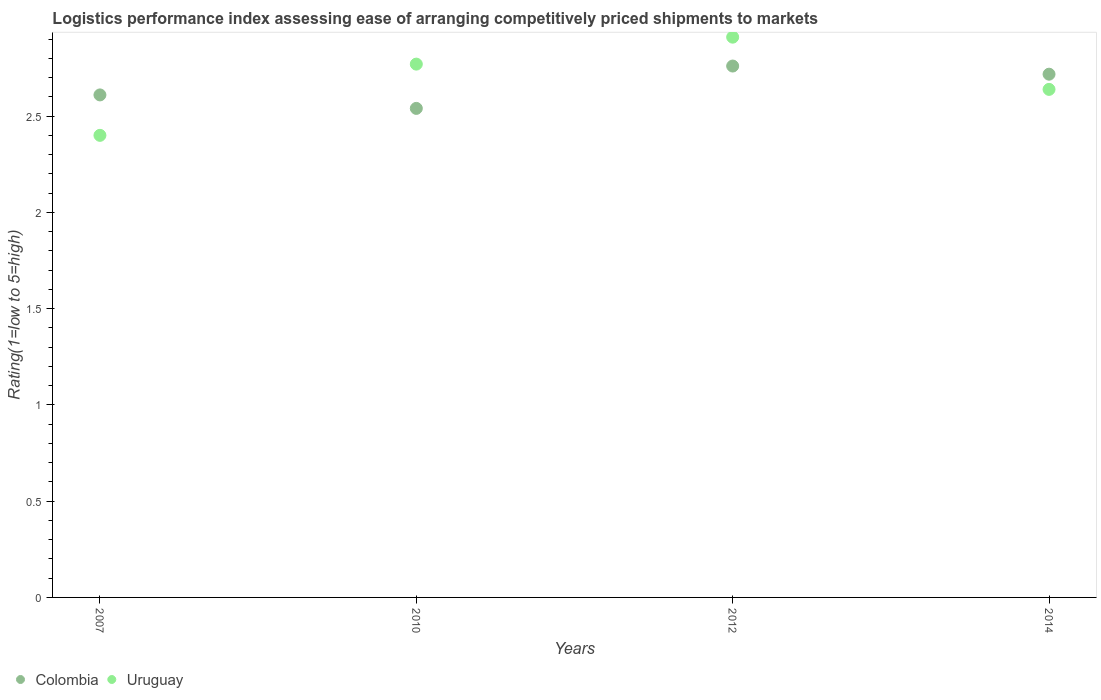Is the number of dotlines equal to the number of legend labels?
Your answer should be compact. Yes. What is the Logistic performance index in Colombia in 2007?
Your answer should be compact. 2.61. Across all years, what is the maximum Logistic performance index in Colombia?
Make the answer very short. 2.76. Across all years, what is the minimum Logistic performance index in Colombia?
Your response must be concise. 2.54. In which year was the Logistic performance index in Colombia minimum?
Your answer should be very brief. 2010. What is the total Logistic performance index in Uruguay in the graph?
Offer a very short reply. 10.72. What is the difference between the Logistic performance index in Uruguay in 2007 and that in 2012?
Offer a terse response. -0.51. What is the difference between the Logistic performance index in Uruguay in 2014 and the Logistic performance index in Colombia in 2007?
Keep it short and to the point. 0.03. What is the average Logistic performance index in Colombia per year?
Your response must be concise. 2.66. In the year 2012, what is the difference between the Logistic performance index in Uruguay and Logistic performance index in Colombia?
Provide a succinct answer. 0.15. In how many years, is the Logistic performance index in Uruguay greater than 1.4?
Offer a terse response. 4. What is the ratio of the Logistic performance index in Uruguay in 2010 to that in 2014?
Provide a short and direct response. 1.05. Is the difference between the Logistic performance index in Uruguay in 2012 and 2014 greater than the difference between the Logistic performance index in Colombia in 2012 and 2014?
Ensure brevity in your answer.  Yes. What is the difference between the highest and the second highest Logistic performance index in Uruguay?
Offer a terse response. 0.14. What is the difference between the highest and the lowest Logistic performance index in Uruguay?
Offer a very short reply. 0.51. In how many years, is the Logistic performance index in Colombia greater than the average Logistic performance index in Colombia taken over all years?
Your answer should be compact. 2. Does the Logistic performance index in Uruguay monotonically increase over the years?
Your answer should be compact. No. How many years are there in the graph?
Your answer should be very brief. 4. What is the difference between two consecutive major ticks on the Y-axis?
Offer a terse response. 0.5. Does the graph contain grids?
Your answer should be very brief. No. Where does the legend appear in the graph?
Offer a very short reply. Bottom left. What is the title of the graph?
Give a very brief answer. Logistics performance index assessing ease of arranging competitively priced shipments to markets. Does "Tuvalu" appear as one of the legend labels in the graph?
Keep it short and to the point. No. What is the label or title of the X-axis?
Your response must be concise. Years. What is the label or title of the Y-axis?
Offer a very short reply. Rating(1=low to 5=high). What is the Rating(1=low to 5=high) of Colombia in 2007?
Your answer should be compact. 2.61. What is the Rating(1=low to 5=high) of Colombia in 2010?
Your response must be concise. 2.54. What is the Rating(1=low to 5=high) in Uruguay in 2010?
Provide a succinct answer. 2.77. What is the Rating(1=low to 5=high) in Colombia in 2012?
Your answer should be compact. 2.76. What is the Rating(1=low to 5=high) of Uruguay in 2012?
Your response must be concise. 2.91. What is the Rating(1=low to 5=high) in Colombia in 2014?
Give a very brief answer. 2.72. What is the Rating(1=low to 5=high) in Uruguay in 2014?
Your answer should be compact. 2.64. Across all years, what is the maximum Rating(1=low to 5=high) in Colombia?
Make the answer very short. 2.76. Across all years, what is the maximum Rating(1=low to 5=high) in Uruguay?
Ensure brevity in your answer.  2.91. Across all years, what is the minimum Rating(1=low to 5=high) of Colombia?
Keep it short and to the point. 2.54. Across all years, what is the minimum Rating(1=low to 5=high) of Uruguay?
Offer a terse response. 2.4. What is the total Rating(1=low to 5=high) in Colombia in the graph?
Give a very brief answer. 10.63. What is the total Rating(1=low to 5=high) in Uruguay in the graph?
Give a very brief answer. 10.72. What is the difference between the Rating(1=low to 5=high) of Colombia in 2007 and that in 2010?
Your answer should be compact. 0.07. What is the difference between the Rating(1=low to 5=high) in Uruguay in 2007 and that in 2010?
Ensure brevity in your answer.  -0.37. What is the difference between the Rating(1=low to 5=high) in Uruguay in 2007 and that in 2012?
Give a very brief answer. -0.51. What is the difference between the Rating(1=low to 5=high) in Colombia in 2007 and that in 2014?
Keep it short and to the point. -0.11. What is the difference between the Rating(1=low to 5=high) of Uruguay in 2007 and that in 2014?
Offer a terse response. -0.24. What is the difference between the Rating(1=low to 5=high) of Colombia in 2010 and that in 2012?
Provide a succinct answer. -0.22. What is the difference between the Rating(1=low to 5=high) of Uruguay in 2010 and that in 2012?
Offer a very short reply. -0.14. What is the difference between the Rating(1=low to 5=high) in Colombia in 2010 and that in 2014?
Offer a terse response. -0.18. What is the difference between the Rating(1=low to 5=high) of Uruguay in 2010 and that in 2014?
Provide a succinct answer. 0.13. What is the difference between the Rating(1=low to 5=high) of Colombia in 2012 and that in 2014?
Your response must be concise. 0.04. What is the difference between the Rating(1=low to 5=high) in Uruguay in 2012 and that in 2014?
Give a very brief answer. 0.27. What is the difference between the Rating(1=low to 5=high) in Colombia in 2007 and the Rating(1=low to 5=high) in Uruguay in 2010?
Make the answer very short. -0.16. What is the difference between the Rating(1=low to 5=high) in Colombia in 2007 and the Rating(1=low to 5=high) in Uruguay in 2012?
Your response must be concise. -0.3. What is the difference between the Rating(1=low to 5=high) in Colombia in 2007 and the Rating(1=low to 5=high) in Uruguay in 2014?
Offer a very short reply. -0.03. What is the difference between the Rating(1=low to 5=high) of Colombia in 2010 and the Rating(1=low to 5=high) of Uruguay in 2012?
Your response must be concise. -0.37. What is the difference between the Rating(1=low to 5=high) in Colombia in 2010 and the Rating(1=low to 5=high) in Uruguay in 2014?
Your response must be concise. -0.1. What is the difference between the Rating(1=low to 5=high) in Colombia in 2012 and the Rating(1=low to 5=high) in Uruguay in 2014?
Provide a short and direct response. 0.12. What is the average Rating(1=low to 5=high) in Colombia per year?
Your response must be concise. 2.66. What is the average Rating(1=low to 5=high) in Uruguay per year?
Offer a very short reply. 2.68. In the year 2007, what is the difference between the Rating(1=low to 5=high) in Colombia and Rating(1=low to 5=high) in Uruguay?
Keep it short and to the point. 0.21. In the year 2010, what is the difference between the Rating(1=low to 5=high) in Colombia and Rating(1=low to 5=high) in Uruguay?
Your answer should be compact. -0.23. In the year 2012, what is the difference between the Rating(1=low to 5=high) in Colombia and Rating(1=low to 5=high) in Uruguay?
Provide a short and direct response. -0.15. In the year 2014, what is the difference between the Rating(1=low to 5=high) in Colombia and Rating(1=low to 5=high) in Uruguay?
Offer a terse response. 0.08. What is the ratio of the Rating(1=low to 5=high) of Colombia in 2007 to that in 2010?
Your response must be concise. 1.03. What is the ratio of the Rating(1=low to 5=high) of Uruguay in 2007 to that in 2010?
Offer a very short reply. 0.87. What is the ratio of the Rating(1=low to 5=high) of Colombia in 2007 to that in 2012?
Offer a terse response. 0.95. What is the ratio of the Rating(1=low to 5=high) in Uruguay in 2007 to that in 2012?
Offer a terse response. 0.82. What is the ratio of the Rating(1=low to 5=high) in Colombia in 2007 to that in 2014?
Offer a very short reply. 0.96. What is the ratio of the Rating(1=low to 5=high) of Uruguay in 2007 to that in 2014?
Your answer should be very brief. 0.91. What is the ratio of the Rating(1=low to 5=high) of Colombia in 2010 to that in 2012?
Provide a short and direct response. 0.92. What is the ratio of the Rating(1=low to 5=high) of Uruguay in 2010 to that in 2012?
Provide a short and direct response. 0.95. What is the ratio of the Rating(1=low to 5=high) in Colombia in 2010 to that in 2014?
Make the answer very short. 0.93. What is the ratio of the Rating(1=low to 5=high) of Uruguay in 2010 to that in 2014?
Provide a short and direct response. 1.05. What is the ratio of the Rating(1=low to 5=high) of Colombia in 2012 to that in 2014?
Ensure brevity in your answer.  1.02. What is the ratio of the Rating(1=low to 5=high) of Uruguay in 2012 to that in 2014?
Your response must be concise. 1.1. What is the difference between the highest and the second highest Rating(1=low to 5=high) in Colombia?
Ensure brevity in your answer.  0.04. What is the difference between the highest and the second highest Rating(1=low to 5=high) in Uruguay?
Make the answer very short. 0.14. What is the difference between the highest and the lowest Rating(1=low to 5=high) of Colombia?
Ensure brevity in your answer.  0.22. What is the difference between the highest and the lowest Rating(1=low to 5=high) of Uruguay?
Offer a very short reply. 0.51. 